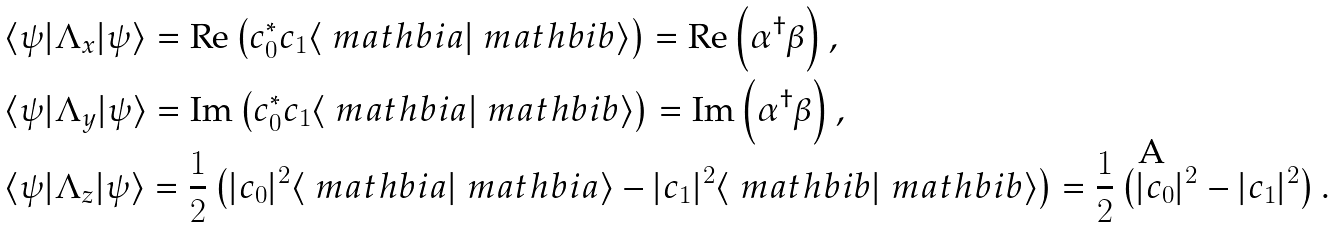<formula> <loc_0><loc_0><loc_500><loc_500>& \langle \psi | \Lambda _ { x } | \psi \rangle = \text {Re} \left ( c _ { 0 } ^ { * } c _ { 1 } \langle \ m a t h b i { a } | \ m a t h b i { b } \rangle \right ) = \text {Re} \left ( \alpha ^ { \dagger } \beta \right ) , \\ & \langle \psi | \Lambda _ { y } | \psi \rangle = \text {Im} \left ( c _ { 0 } ^ { * } c _ { 1 } \langle \ m a t h b i { a } | \ m a t h b i { b } \rangle \right ) = \text {Im} \left ( \alpha ^ { \dagger } \beta \right ) , \\ & \langle \psi | \Lambda _ { z } | \psi \rangle = \frac { 1 } { 2 } \left ( | c _ { 0 } | ^ { 2 } \langle \ m a t h b i { a } | \ m a t h b i { a } \rangle - | c _ { 1 } | ^ { 2 } \langle \ m a t h b i { b } | \ m a t h b i { b } \rangle \right ) = \frac { 1 } { 2 } \left ( | c _ { 0 } | ^ { 2 } - | c _ { 1 } | ^ { 2 } \right ) .</formula> 